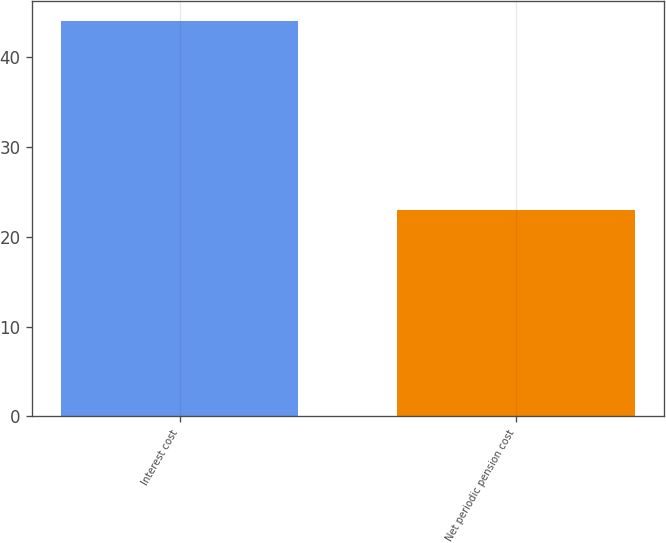<chart> <loc_0><loc_0><loc_500><loc_500><bar_chart><fcel>Interest cost<fcel>Net periodic pension cost<nl><fcel>44<fcel>23<nl></chart> 